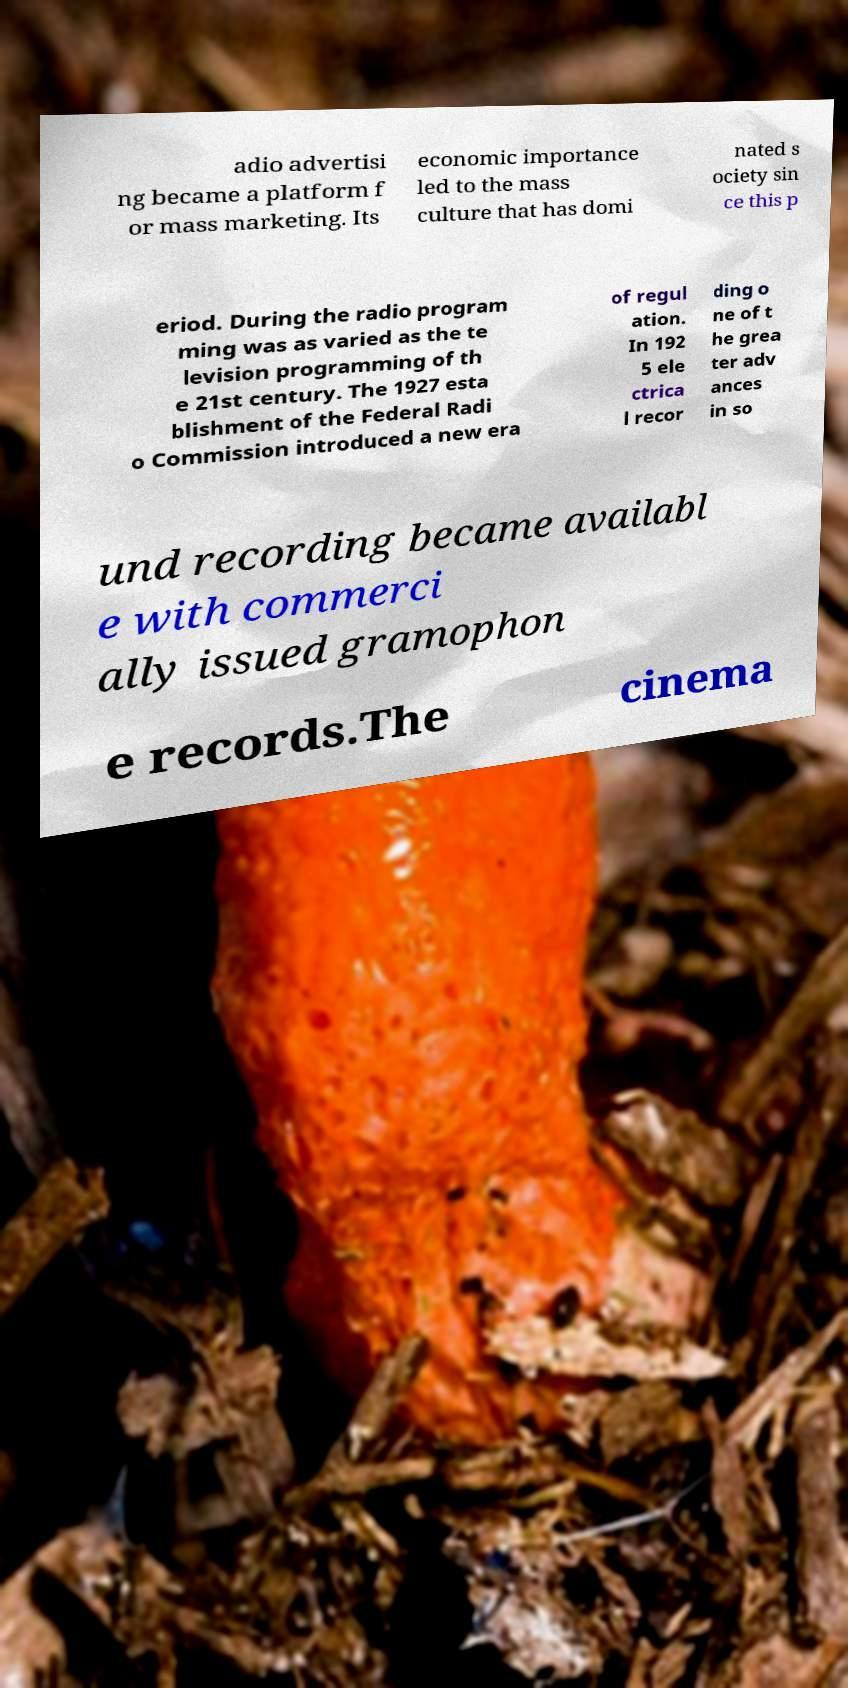Can you read and provide the text displayed in the image?This photo seems to have some interesting text. Can you extract and type it out for me? adio advertisi ng became a platform f or mass marketing. Its economic importance led to the mass culture that has domi nated s ociety sin ce this p eriod. During the radio program ming was as varied as the te levision programming of th e 21st century. The 1927 esta blishment of the Federal Radi o Commission introduced a new era of regul ation. In 192 5 ele ctrica l recor ding o ne of t he grea ter adv ances in so und recording became availabl e with commerci ally issued gramophon e records.The cinema 